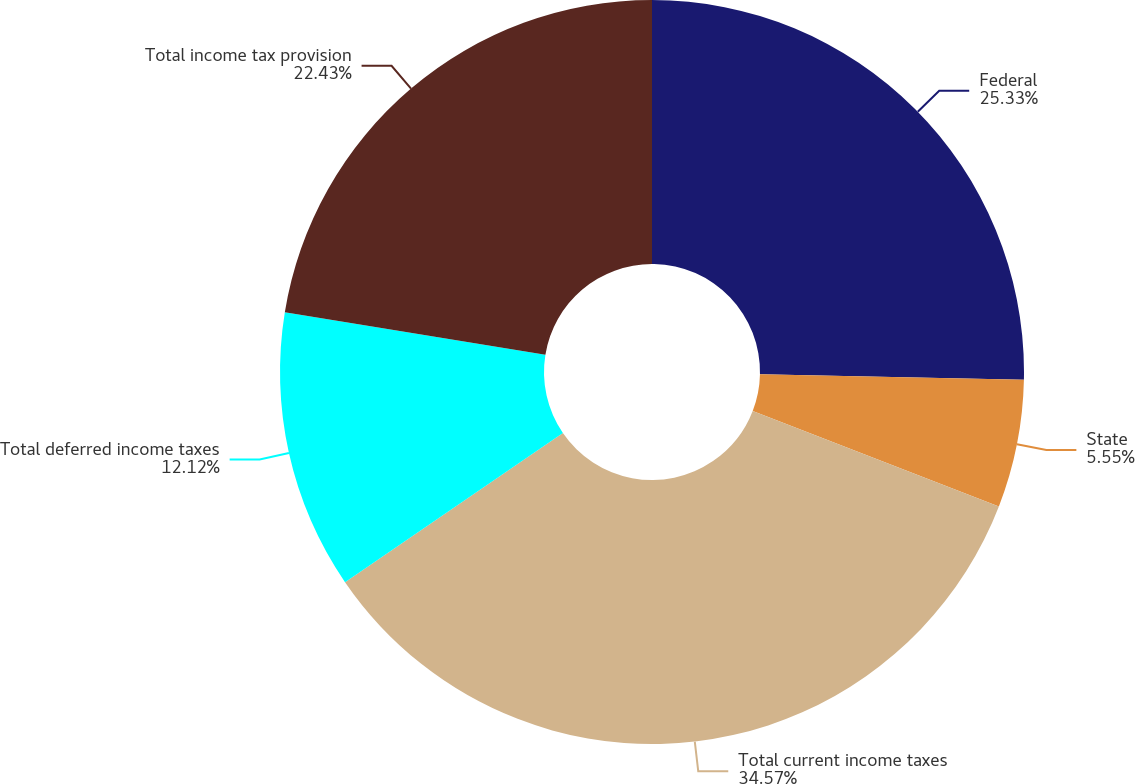Convert chart to OTSL. <chart><loc_0><loc_0><loc_500><loc_500><pie_chart><fcel>Federal<fcel>State<fcel>Total current income taxes<fcel>Total deferred income taxes<fcel>Total income tax provision<nl><fcel>25.33%<fcel>5.55%<fcel>34.56%<fcel>12.12%<fcel>22.43%<nl></chart> 